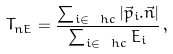Convert formula to latex. <formula><loc_0><loc_0><loc_500><loc_500>T _ { n E } = \frac { \sum _ { i \in \ h c } | \vec { p } _ { i } . \vec { n } | } { \sum _ { i \in \ h c } E _ { i } } \, ,</formula> 